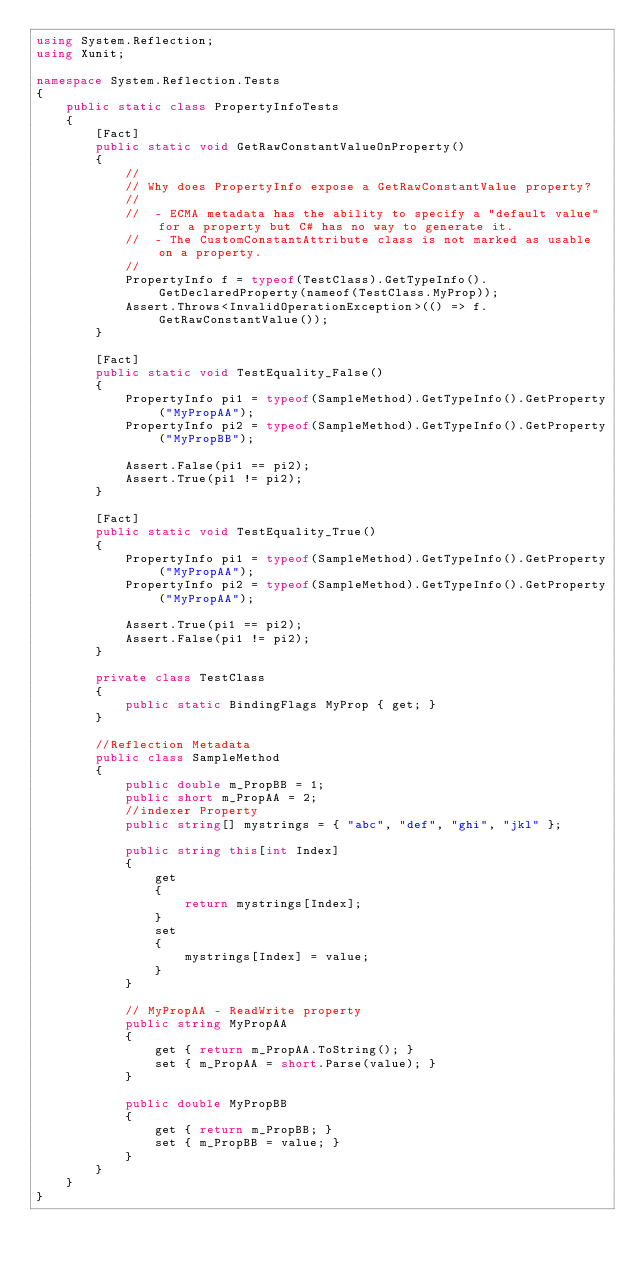Convert code to text. <code><loc_0><loc_0><loc_500><loc_500><_C#_>using System.Reflection;
using Xunit;

namespace System.Reflection.Tests
{
    public static class PropertyInfoTests
    {
        [Fact]
        public static void GetRawConstantValueOnProperty()
        {
            //
            // Why does PropertyInfo expose a GetRawConstantValue property?
            //
            //  - ECMA metadata has the ability to specify a "default value" for a property but C# has no way to generate it.
            //  - The CustomConstantAttribute class is not marked as usable on a property.
            // 
            PropertyInfo f = typeof(TestClass).GetTypeInfo().GetDeclaredProperty(nameof(TestClass.MyProp));
            Assert.Throws<InvalidOperationException>(() => f.GetRawConstantValue());
        }
    
        [Fact]
        public static void TestEquality_False()
        {
            PropertyInfo pi1 = typeof(SampleMethod).GetTypeInfo().GetProperty("MyPropAA");
            PropertyInfo pi2 = typeof(SampleMethod).GetTypeInfo().GetProperty("MyPropBB");

            Assert.False(pi1 == pi2);
            Assert.True(pi1 != pi2);
        }

        [Fact]
        public static void TestEquality_True()
        {
            PropertyInfo pi1 = typeof(SampleMethod).GetTypeInfo().GetProperty("MyPropAA");
            PropertyInfo pi2 = typeof(SampleMethod).GetTypeInfo().GetProperty("MyPropAA");

            Assert.True(pi1 == pi2);
            Assert.False(pi1 != pi2);
        }

        private class TestClass
        {
            public static BindingFlags MyProp { get; }
        }

        //Reflection Metadata
        public class SampleMethod
        {
            public double m_PropBB = 1;
            public short m_PropAA = 2;
            //indexer Property
            public string[] mystrings = { "abc", "def", "ghi", "jkl" };

            public string this[int Index]
            {
                get
                {
                    return mystrings[Index];
                }
                set
                {
                    mystrings[Index] = value;
                }
            }

            // MyPropAA - ReadWrite property
            public string MyPropAA
            {
                get { return m_PropAA.ToString(); }
                set { m_PropAA = short.Parse(value); }
            }

            public double MyPropBB
            {
                get { return m_PropBB; }
                set { m_PropBB = value; }
            }
        }
    }
}</code> 